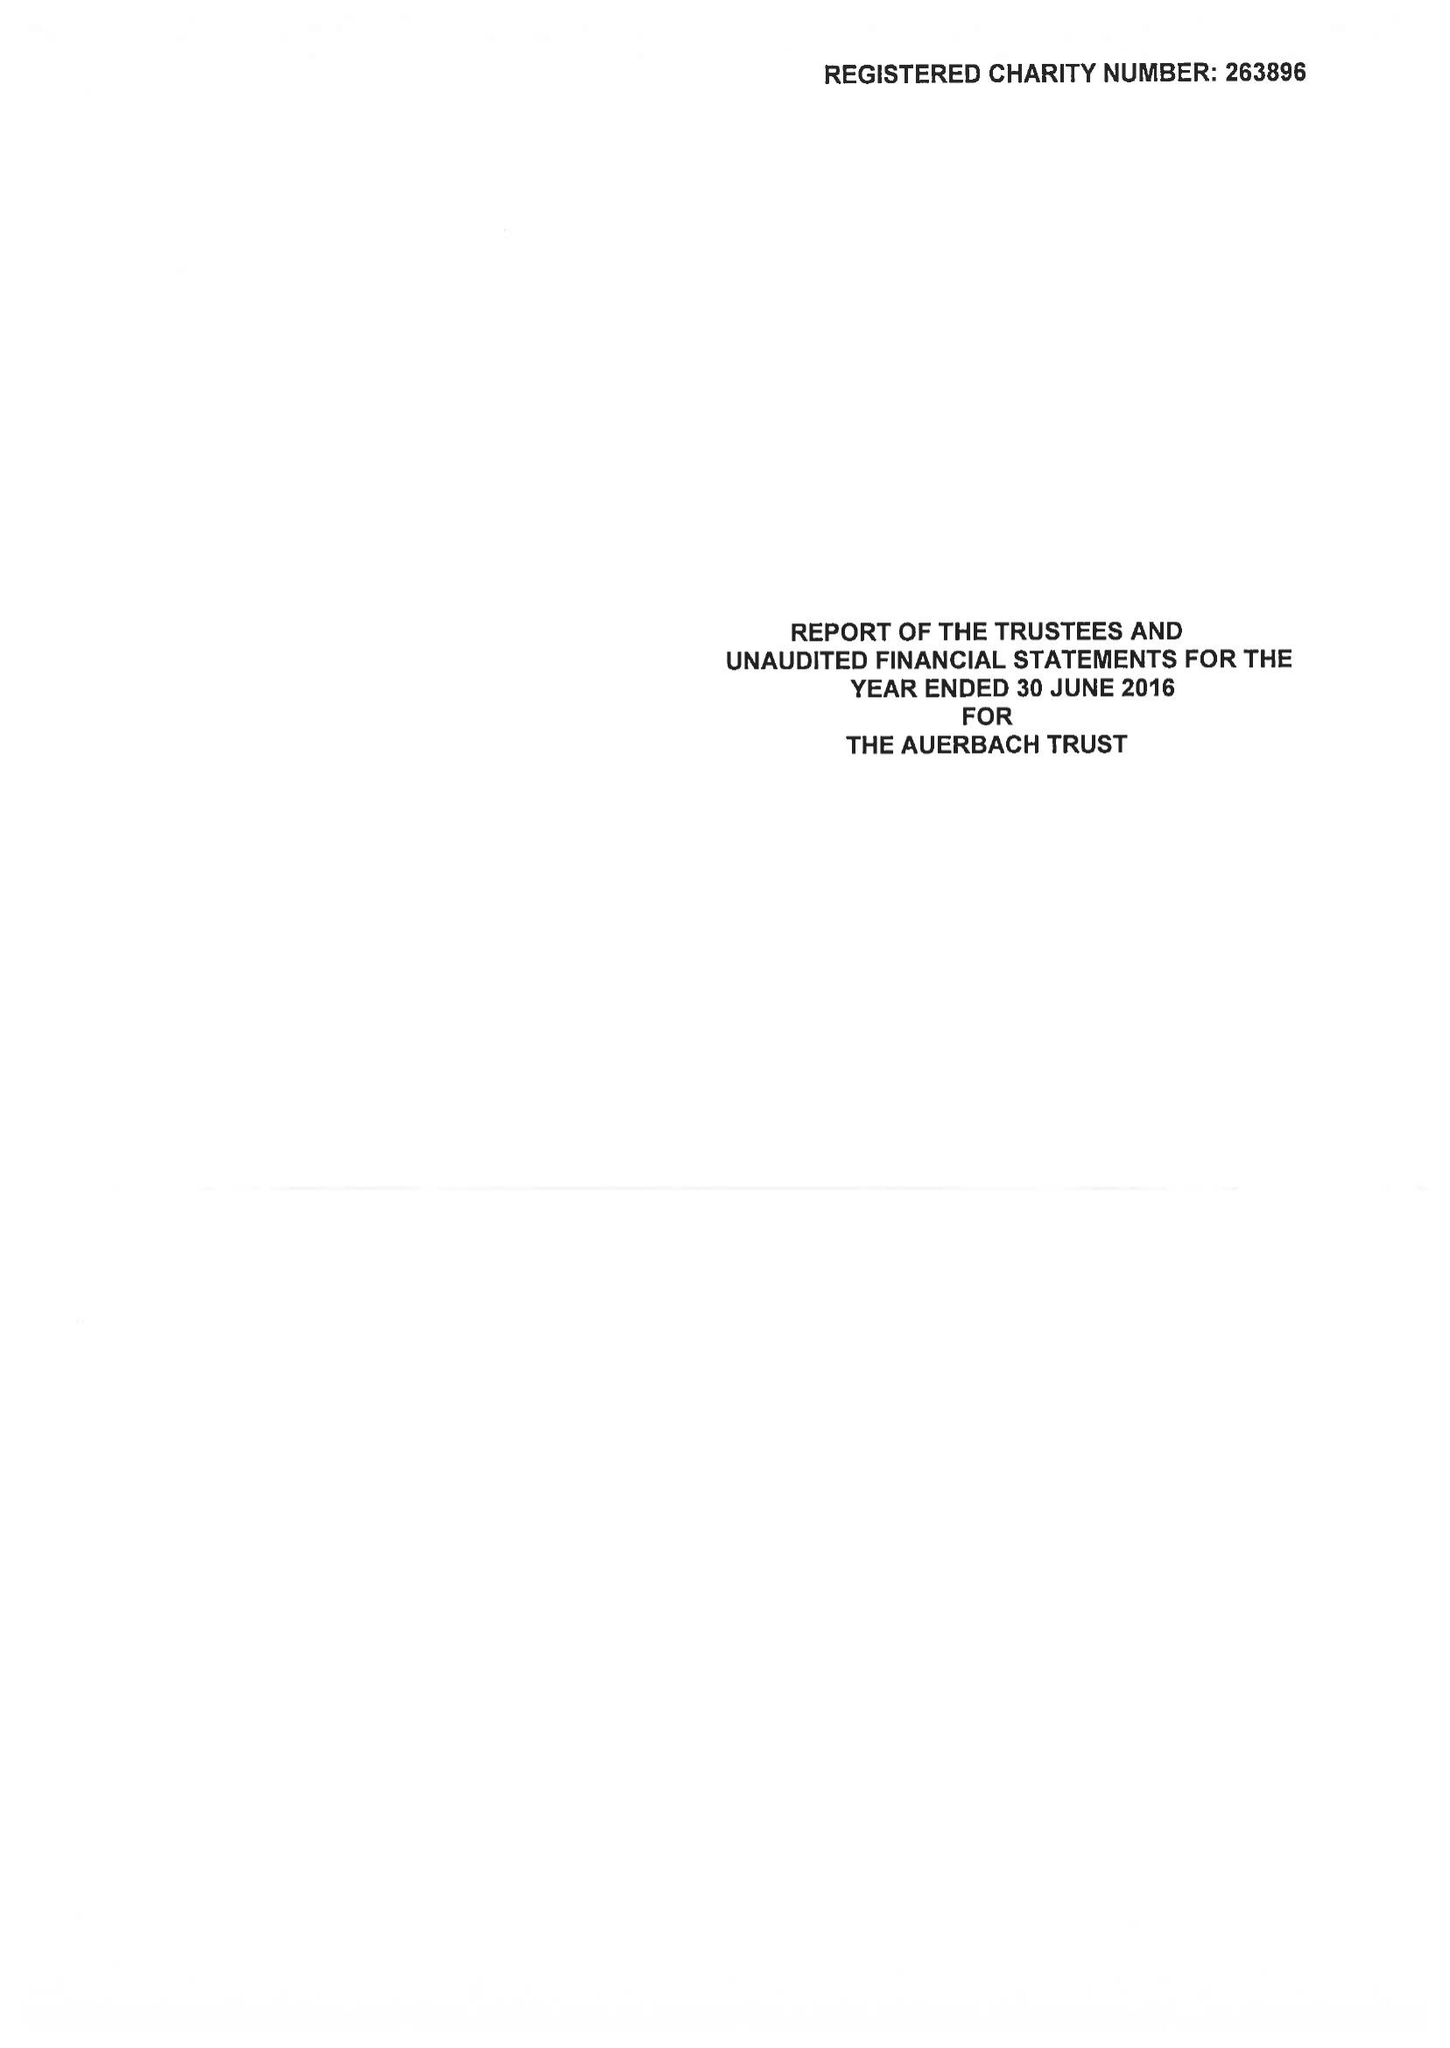What is the value for the spending_annually_in_british_pounds?
Answer the question using a single word or phrase. 27433.00 